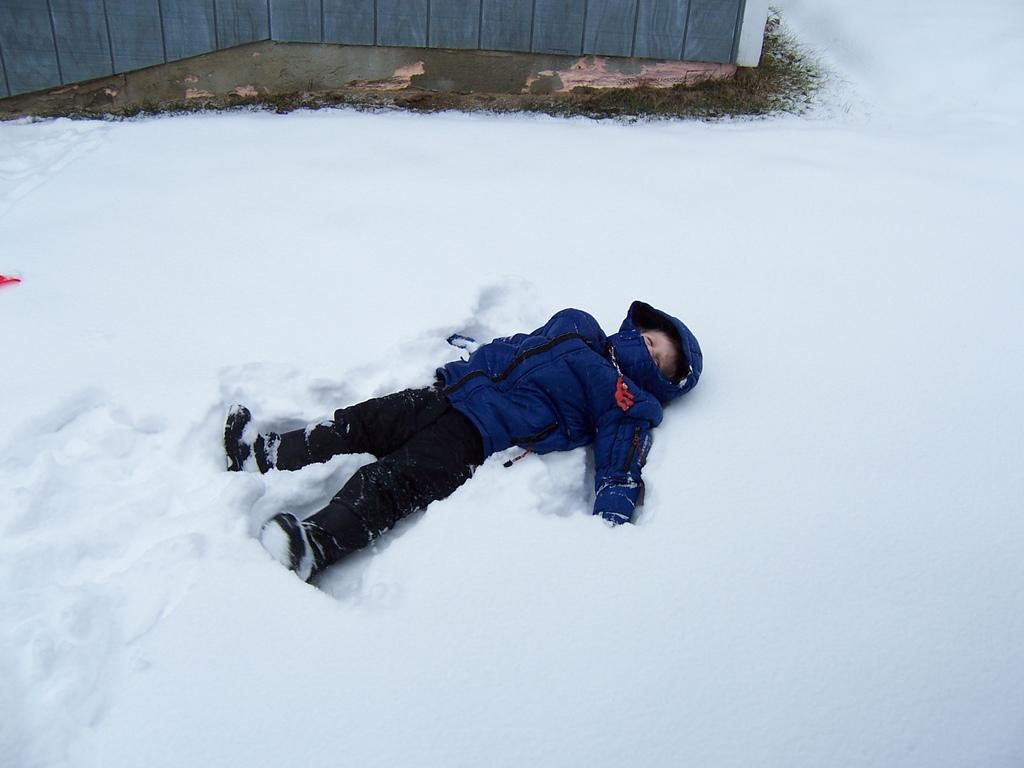What is the main subject of the image? There is a kid in the image. What is the kid doing in the image? The kid is lying on the snow. What can be seen at the top of the image? There are wooden boards visible at the top of the image. What type of pipe is the kid holding in the image? There is no pipe present in the image; the kid is lying on the snow with no visible objects in their hands. 